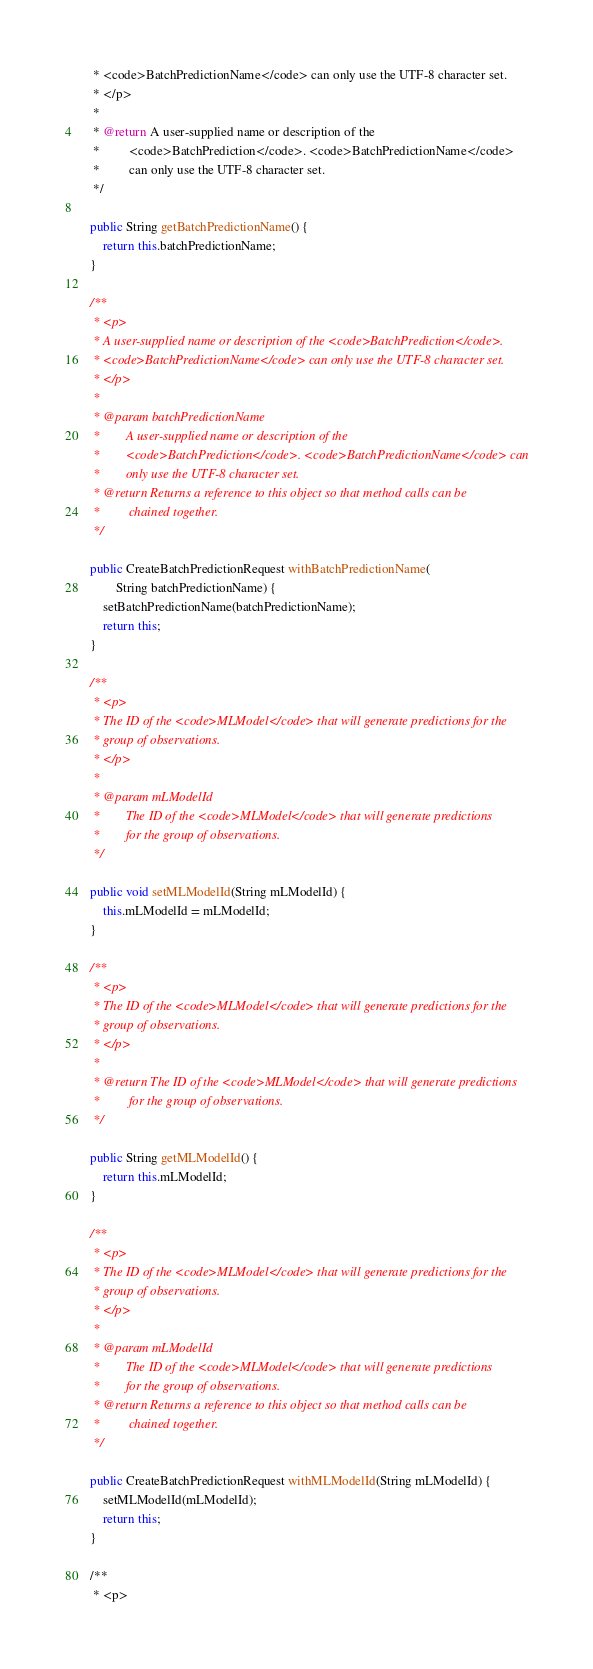Convert code to text. <code><loc_0><loc_0><loc_500><loc_500><_Java_>     * <code>BatchPredictionName</code> can only use the UTF-8 character set.
     * </p>
     * 
     * @return A user-supplied name or description of the
     *         <code>BatchPrediction</code>. <code>BatchPredictionName</code>
     *         can only use the UTF-8 character set.
     */

    public String getBatchPredictionName() {
        return this.batchPredictionName;
    }

    /**
     * <p>
     * A user-supplied name or description of the <code>BatchPrediction</code>.
     * <code>BatchPredictionName</code> can only use the UTF-8 character set.
     * </p>
     * 
     * @param batchPredictionName
     *        A user-supplied name or description of the
     *        <code>BatchPrediction</code>. <code>BatchPredictionName</code> can
     *        only use the UTF-8 character set.
     * @return Returns a reference to this object so that method calls can be
     *         chained together.
     */

    public CreateBatchPredictionRequest withBatchPredictionName(
            String batchPredictionName) {
        setBatchPredictionName(batchPredictionName);
        return this;
    }

    /**
     * <p>
     * The ID of the <code>MLModel</code> that will generate predictions for the
     * group of observations.
     * </p>
     * 
     * @param mLModelId
     *        The ID of the <code>MLModel</code> that will generate predictions
     *        for the group of observations.
     */

    public void setMLModelId(String mLModelId) {
        this.mLModelId = mLModelId;
    }

    /**
     * <p>
     * The ID of the <code>MLModel</code> that will generate predictions for the
     * group of observations.
     * </p>
     * 
     * @return The ID of the <code>MLModel</code> that will generate predictions
     *         for the group of observations.
     */

    public String getMLModelId() {
        return this.mLModelId;
    }

    /**
     * <p>
     * The ID of the <code>MLModel</code> that will generate predictions for the
     * group of observations.
     * </p>
     * 
     * @param mLModelId
     *        The ID of the <code>MLModel</code> that will generate predictions
     *        for the group of observations.
     * @return Returns a reference to this object so that method calls can be
     *         chained together.
     */

    public CreateBatchPredictionRequest withMLModelId(String mLModelId) {
        setMLModelId(mLModelId);
        return this;
    }

    /**
     * <p></code> 